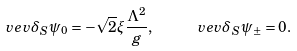Convert formula to latex. <formula><loc_0><loc_0><loc_500><loc_500>\ v e v { \delta _ { S } \psi _ { 0 } } = - \sqrt { 2 } \xi \frac { \Lambda ^ { 2 } } { g } , \quad \ v e v { \delta _ { S } \psi _ { \pm } } = 0 .</formula> 